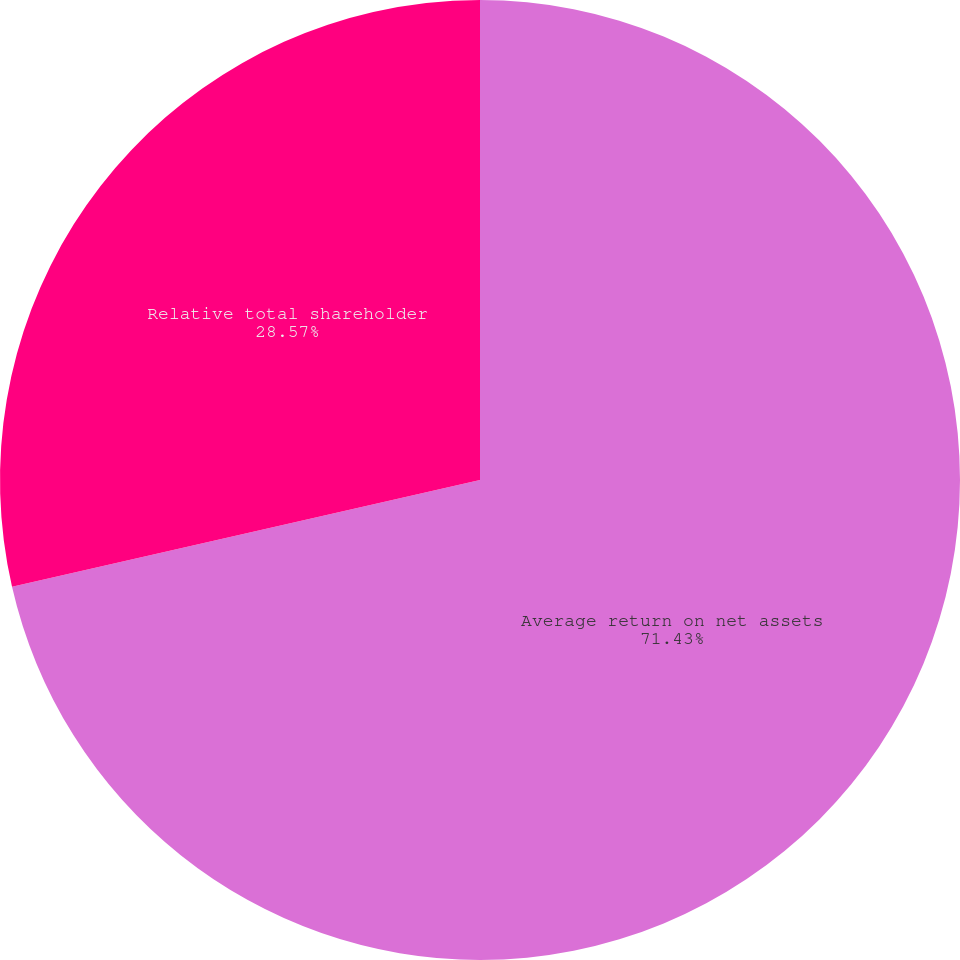Convert chart to OTSL. <chart><loc_0><loc_0><loc_500><loc_500><pie_chart><fcel>Average return on net assets<fcel>Relative total shareholder<nl><fcel>71.43%<fcel>28.57%<nl></chart> 